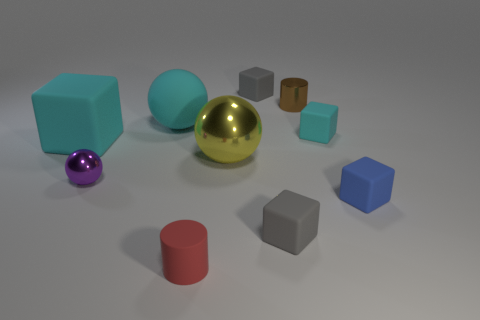There is a small purple thing that is the same material as the large yellow object; what is its shape?
Your response must be concise. Sphere. What is the size of the cyan ball that is made of the same material as the blue thing?
Provide a succinct answer. Large. What is the shape of the small thing that is both behind the large metallic thing and in front of the tiny brown shiny cylinder?
Your response must be concise. Cube. What is the size of the gray rubber thing that is in front of the small gray matte thing that is behind the big cyan cube?
Give a very brief answer. Small. How many other objects are there of the same color as the big metallic sphere?
Ensure brevity in your answer.  0. What is the material of the tiny red thing?
Your response must be concise. Rubber. Are there any yellow objects?
Provide a succinct answer. Yes. Is the number of blue objects that are right of the small brown metal object the same as the number of tiny objects?
Make the answer very short. No. Is there any other thing that has the same material as the yellow ball?
Offer a terse response. Yes. How many big objects are either cyan cubes or blue rubber objects?
Offer a very short reply. 1. 